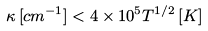<formula> <loc_0><loc_0><loc_500><loc_500>\kappa \, [ c m ^ { - 1 } ] < 4 \times 1 0 ^ { 5 } T ^ { 1 / 2 } \, [ K ]</formula> 